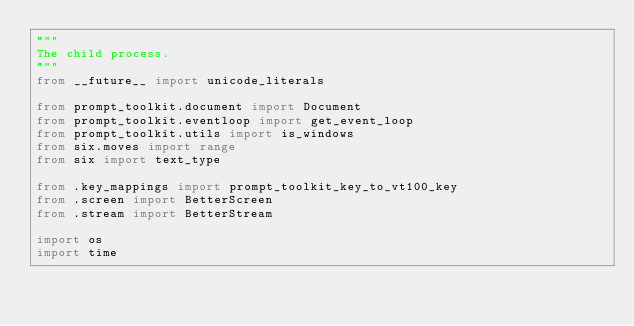Convert code to text. <code><loc_0><loc_0><loc_500><loc_500><_Python_>"""
The child process.
"""
from __future__ import unicode_literals

from prompt_toolkit.document import Document
from prompt_toolkit.eventloop import get_event_loop
from prompt_toolkit.utils import is_windows
from six.moves import range
from six import text_type

from .key_mappings import prompt_toolkit_key_to_vt100_key
from .screen import BetterScreen
from .stream import BetterStream

import os
import time
</code> 